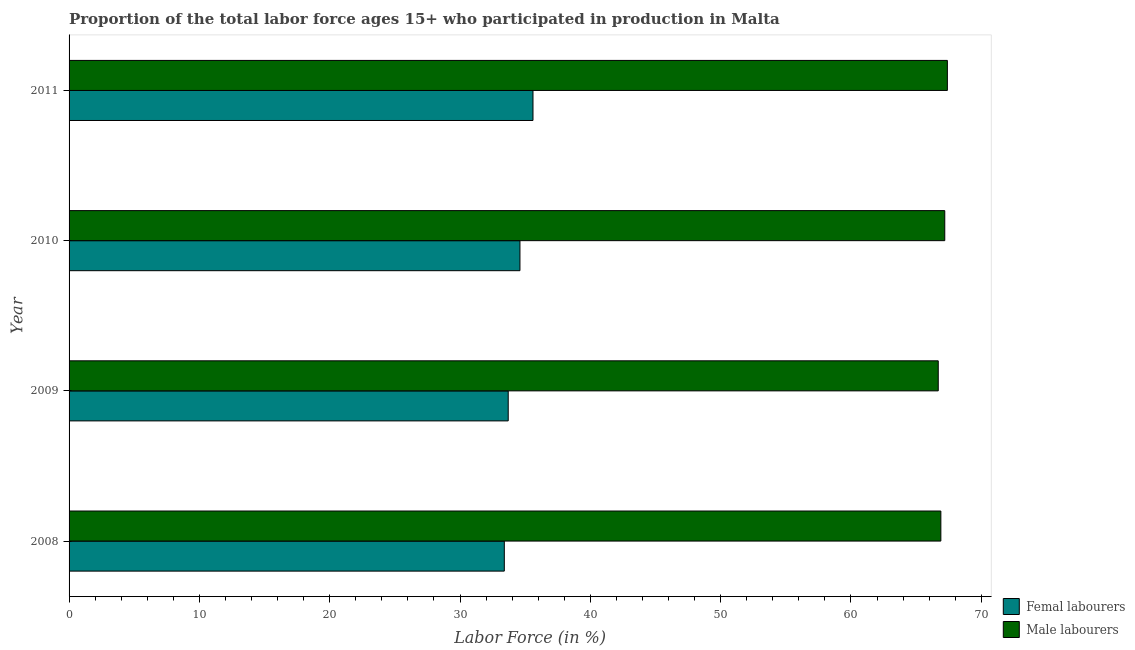Are the number of bars per tick equal to the number of legend labels?
Give a very brief answer. Yes. Are the number of bars on each tick of the Y-axis equal?
Make the answer very short. Yes. How many bars are there on the 1st tick from the top?
Give a very brief answer. 2. In how many cases, is the number of bars for a given year not equal to the number of legend labels?
Provide a succinct answer. 0. What is the percentage of male labour force in 2009?
Your answer should be very brief. 66.7. Across all years, what is the maximum percentage of male labour force?
Offer a terse response. 67.4. Across all years, what is the minimum percentage of female labor force?
Ensure brevity in your answer.  33.4. What is the total percentage of female labor force in the graph?
Keep it short and to the point. 137.3. What is the difference between the percentage of male labour force in 2009 and the percentage of female labor force in 2011?
Ensure brevity in your answer.  31.1. What is the average percentage of male labour force per year?
Give a very brief answer. 67.05. In the year 2009, what is the difference between the percentage of female labor force and percentage of male labour force?
Offer a terse response. -33. In how many years, is the percentage of female labor force greater than 52 %?
Make the answer very short. 0. Is the difference between the percentage of female labor force in 2008 and 2011 greater than the difference between the percentage of male labour force in 2008 and 2011?
Ensure brevity in your answer.  No. In how many years, is the percentage of female labor force greater than the average percentage of female labor force taken over all years?
Offer a very short reply. 2. What does the 1st bar from the top in 2009 represents?
Your response must be concise. Male labourers. What does the 2nd bar from the bottom in 2009 represents?
Give a very brief answer. Male labourers. How many bars are there?
Give a very brief answer. 8. How many years are there in the graph?
Offer a terse response. 4. Are the values on the major ticks of X-axis written in scientific E-notation?
Your answer should be very brief. No. Does the graph contain any zero values?
Your response must be concise. No. Does the graph contain grids?
Give a very brief answer. No. What is the title of the graph?
Your response must be concise. Proportion of the total labor force ages 15+ who participated in production in Malta. Does "Forest" appear as one of the legend labels in the graph?
Your response must be concise. No. What is the label or title of the X-axis?
Your response must be concise. Labor Force (in %). What is the Labor Force (in %) in Femal labourers in 2008?
Offer a very short reply. 33.4. What is the Labor Force (in %) of Male labourers in 2008?
Ensure brevity in your answer.  66.9. What is the Labor Force (in %) in Femal labourers in 2009?
Ensure brevity in your answer.  33.7. What is the Labor Force (in %) of Male labourers in 2009?
Offer a very short reply. 66.7. What is the Labor Force (in %) in Femal labourers in 2010?
Offer a terse response. 34.6. What is the Labor Force (in %) of Male labourers in 2010?
Your answer should be very brief. 67.2. What is the Labor Force (in %) in Femal labourers in 2011?
Make the answer very short. 35.6. What is the Labor Force (in %) in Male labourers in 2011?
Your answer should be compact. 67.4. Across all years, what is the maximum Labor Force (in %) of Femal labourers?
Ensure brevity in your answer.  35.6. Across all years, what is the maximum Labor Force (in %) of Male labourers?
Offer a terse response. 67.4. Across all years, what is the minimum Labor Force (in %) in Femal labourers?
Give a very brief answer. 33.4. Across all years, what is the minimum Labor Force (in %) of Male labourers?
Keep it short and to the point. 66.7. What is the total Labor Force (in %) in Femal labourers in the graph?
Your answer should be compact. 137.3. What is the total Labor Force (in %) of Male labourers in the graph?
Make the answer very short. 268.2. What is the difference between the Labor Force (in %) in Femal labourers in 2008 and that in 2009?
Make the answer very short. -0.3. What is the difference between the Labor Force (in %) of Male labourers in 2008 and that in 2009?
Give a very brief answer. 0.2. What is the difference between the Labor Force (in %) in Femal labourers in 2008 and that in 2011?
Your answer should be compact. -2.2. What is the difference between the Labor Force (in %) of Male labourers in 2008 and that in 2011?
Your answer should be compact. -0.5. What is the difference between the Labor Force (in %) of Femal labourers in 2009 and that in 2010?
Your answer should be compact. -0.9. What is the difference between the Labor Force (in %) of Male labourers in 2009 and that in 2011?
Provide a succinct answer. -0.7. What is the difference between the Labor Force (in %) of Femal labourers in 2010 and that in 2011?
Keep it short and to the point. -1. What is the difference between the Labor Force (in %) of Femal labourers in 2008 and the Labor Force (in %) of Male labourers in 2009?
Your answer should be very brief. -33.3. What is the difference between the Labor Force (in %) of Femal labourers in 2008 and the Labor Force (in %) of Male labourers in 2010?
Offer a terse response. -33.8. What is the difference between the Labor Force (in %) of Femal labourers in 2008 and the Labor Force (in %) of Male labourers in 2011?
Your response must be concise. -34. What is the difference between the Labor Force (in %) of Femal labourers in 2009 and the Labor Force (in %) of Male labourers in 2010?
Your answer should be very brief. -33.5. What is the difference between the Labor Force (in %) in Femal labourers in 2009 and the Labor Force (in %) in Male labourers in 2011?
Your response must be concise. -33.7. What is the difference between the Labor Force (in %) of Femal labourers in 2010 and the Labor Force (in %) of Male labourers in 2011?
Offer a very short reply. -32.8. What is the average Labor Force (in %) in Femal labourers per year?
Your answer should be very brief. 34.33. What is the average Labor Force (in %) of Male labourers per year?
Ensure brevity in your answer.  67.05. In the year 2008, what is the difference between the Labor Force (in %) in Femal labourers and Labor Force (in %) in Male labourers?
Your answer should be compact. -33.5. In the year 2009, what is the difference between the Labor Force (in %) of Femal labourers and Labor Force (in %) of Male labourers?
Your answer should be very brief. -33. In the year 2010, what is the difference between the Labor Force (in %) of Femal labourers and Labor Force (in %) of Male labourers?
Give a very brief answer. -32.6. In the year 2011, what is the difference between the Labor Force (in %) in Femal labourers and Labor Force (in %) in Male labourers?
Keep it short and to the point. -31.8. What is the ratio of the Labor Force (in %) in Femal labourers in 2008 to that in 2010?
Keep it short and to the point. 0.97. What is the ratio of the Labor Force (in %) of Femal labourers in 2008 to that in 2011?
Provide a short and direct response. 0.94. What is the ratio of the Labor Force (in %) of Male labourers in 2008 to that in 2011?
Ensure brevity in your answer.  0.99. What is the ratio of the Labor Force (in %) of Femal labourers in 2009 to that in 2010?
Ensure brevity in your answer.  0.97. What is the ratio of the Labor Force (in %) in Male labourers in 2009 to that in 2010?
Make the answer very short. 0.99. What is the ratio of the Labor Force (in %) in Femal labourers in 2009 to that in 2011?
Provide a short and direct response. 0.95. What is the ratio of the Labor Force (in %) in Femal labourers in 2010 to that in 2011?
Provide a short and direct response. 0.97. What is the ratio of the Labor Force (in %) of Male labourers in 2010 to that in 2011?
Ensure brevity in your answer.  1. What is the difference between the highest and the second highest Labor Force (in %) in Femal labourers?
Your response must be concise. 1. What is the difference between the highest and the second highest Labor Force (in %) in Male labourers?
Offer a terse response. 0.2. What is the difference between the highest and the lowest Labor Force (in %) in Femal labourers?
Ensure brevity in your answer.  2.2. 